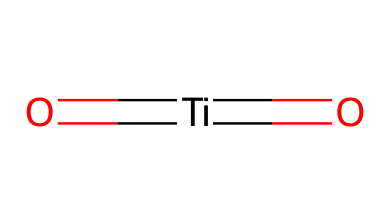What is the central atom in titanium dioxide? The SMILES representation shows "Ti" is at the center of "O=[Ti]=O", indicating that titanium (Ti) is the central atom in this molecule.
Answer: titanium How many oxygen atoms are present in titanium dioxide? In the SMILES representation "O=[Ti]=O", there are two oxygen atoms (O) connected to the central titanium atom.
Answer: two What is the oxidation state of titanium in titanium dioxide? The bonding indicates that titanium is bonded to two oxygen atoms with double bonds; typically in this structure, titanium has an oxidation state of +4.
Answer: +4 What type of bonds are formed between titanium and oxygen in titanium dioxide? The structure reveals double bonds (indicated by "=["), meaning the bonds between titanium and oxygen are covalent and specifically double bonds.
Answer: double bonds Is titanium dioxide a semiconductor? Titanium dioxide has properties that allow it to conduct electricity under certain conditions, classifying it as a semiconductor.
Answer: yes What is the primary application of titanium dioxide in self-cleaning windows? In self-cleaning applications, titanium dioxide acts as a photocatalyst, which enables the breakdown of organic matter when exposed to light.
Answer: photocatalyst 